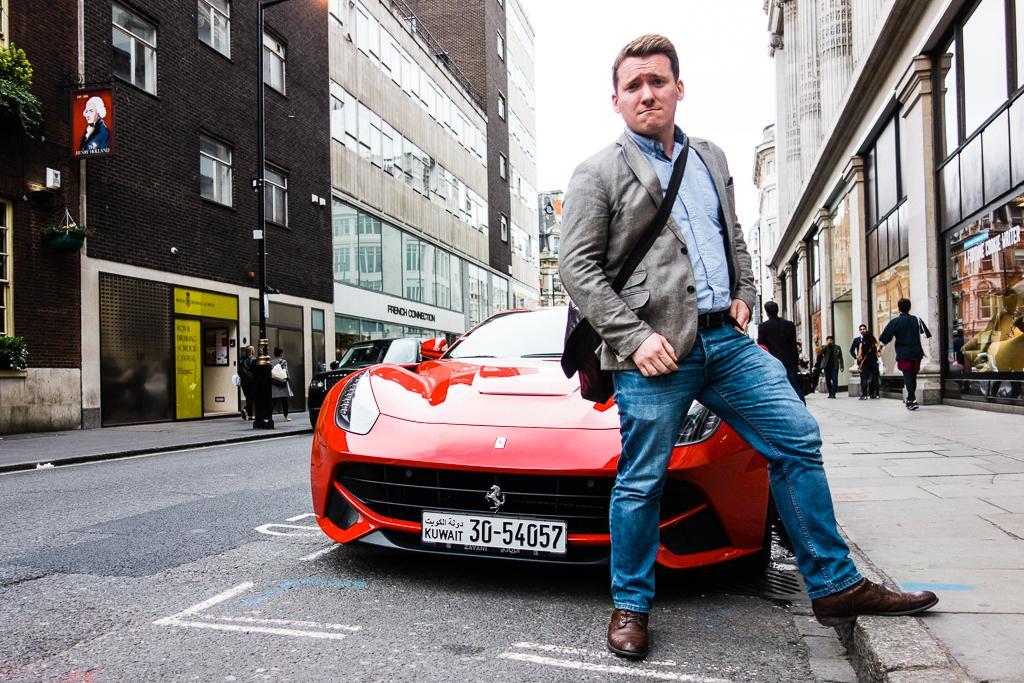In one or two sentences, can you explain what this image depicts? In this picture there is a man who is standing near to the red car. On the right I can see many people who are walking on the street. Beside them I can see the posters on the wall. On the left I can see black color car which is parked near to the bench and street light. In the back I can see the buildings. At the top I can see the sky. In the top left I can see the pole, tree and poster of a person. 